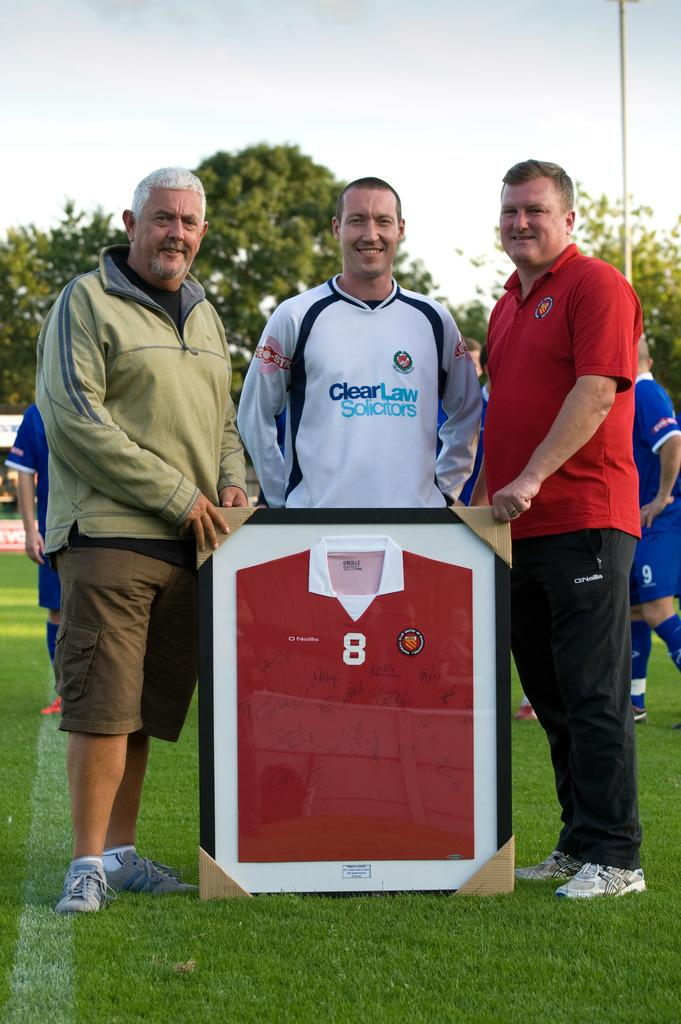<image>
Provide a brief description of the given image. a man wearing a clear law solicitors jersey 